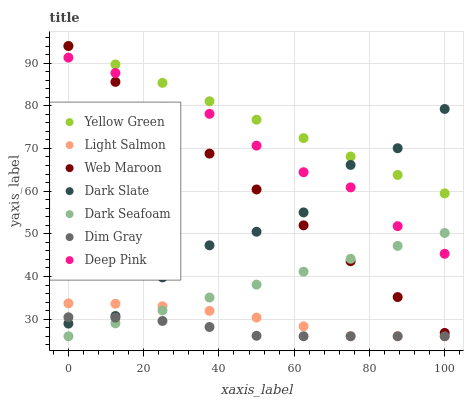Does Dim Gray have the minimum area under the curve?
Answer yes or no. Yes. Does Yellow Green have the maximum area under the curve?
Answer yes or no. Yes. Does Yellow Green have the minimum area under the curve?
Answer yes or no. No. Does Dim Gray have the maximum area under the curve?
Answer yes or no. No. Is Web Maroon the smoothest?
Answer yes or no. Yes. Is Dark Slate the roughest?
Answer yes or no. Yes. Is Dim Gray the smoothest?
Answer yes or no. No. Is Dim Gray the roughest?
Answer yes or no. No. Does Light Salmon have the lowest value?
Answer yes or no. Yes. Does Yellow Green have the lowest value?
Answer yes or no. No. Does Web Maroon have the highest value?
Answer yes or no. Yes. Does Dim Gray have the highest value?
Answer yes or no. No. Is Deep Pink less than Yellow Green?
Answer yes or no. Yes. Is Yellow Green greater than Deep Pink?
Answer yes or no. Yes. Does Dark Slate intersect Web Maroon?
Answer yes or no. Yes. Is Dark Slate less than Web Maroon?
Answer yes or no. No. Is Dark Slate greater than Web Maroon?
Answer yes or no. No. Does Deep Pink intersect Yellow Green?
Answer yes or no. No. 